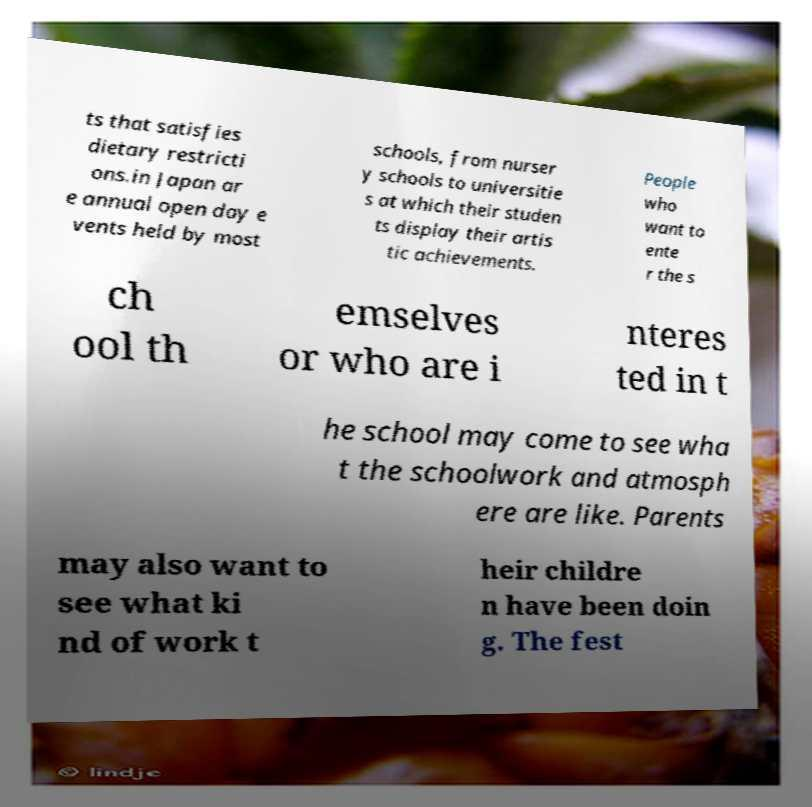Please identify and transcribe the text found in this image. ts that satisfies dietary restricti ons.in Japan ar e annual open day e vents held by most schools, from nurser y schools to universitie s at which their studen ts display their artis tic achievements. People who want to ente r the s ch ool th emselves or who are i nteres ted in t he school may come to see wha t the schoolwork and atmosph ere are like. Parents may also want to see what ki nd of work t heir childre n have been doin g. The fest 